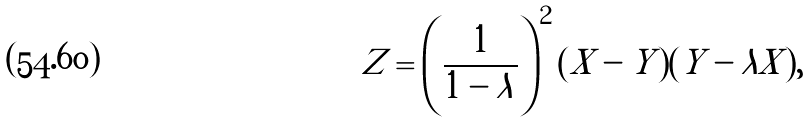<formula> <loc_0><loc_0><loc_500><loc_500>Z = \left ( \frac { 1 } { 1 - \lambda } \right ) ^ { 2 } ( X - Y ) ( Y - \lambda X ) ,</formula> 